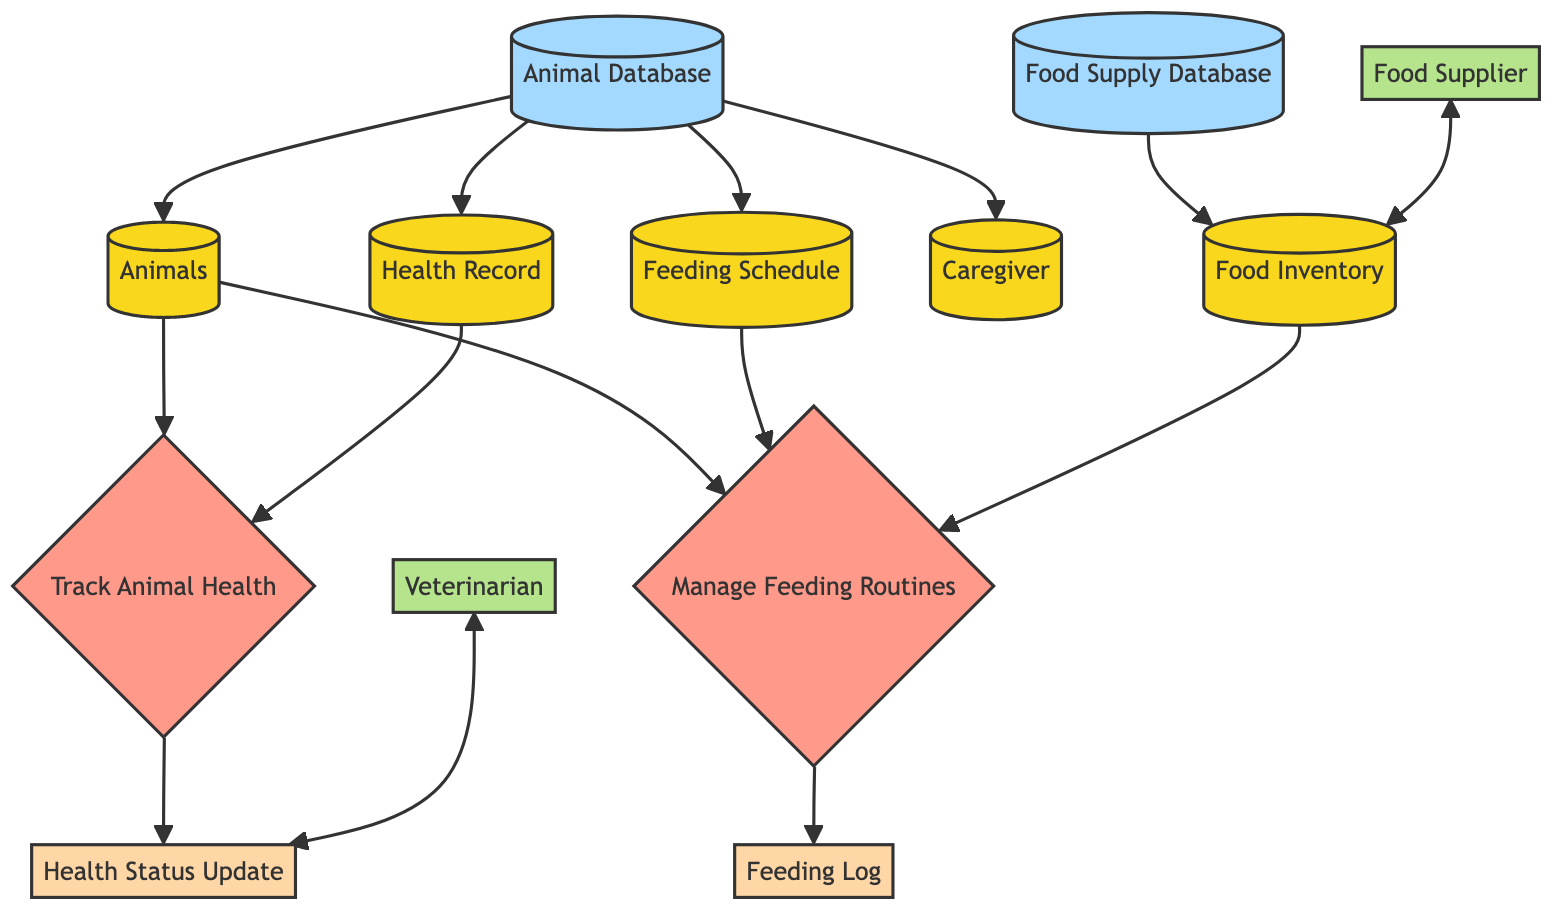What is the process that handles animal health tracking? The diagram shows a process node labeled "Track Animal Health," which is responsible for managing health records and updating health status. It takes input from "HealthRecord" and "AnimalID" and produces an output "HealthStatusUpdate."
Answer: Track Animal Health How many entities are there in the diagram? By counting the nodes labeled as entities, we identify five: "Animals," "Feeding Schedule," "Health Record," "Caregiver," and "Food Inventory."
Answer: 5 What is the output generated by the process "Manage Feeding Routines"? Following the flowchart, the output node that is linked from the "Manage Feeding Routines" process is labeled "Feeding Log," showing that this process produces a log related to feeding activities.
Answer: Feeding Log Which external entity interacts with the "Health Status Update"? The diagram indicates that there is a two-way interaction labeled between the "Veterinarian" external entity and the output "Health Status Update," meaning the veterinarian is involved in this aspect of the system.
Answer: Veterinarian Which data store contains information about animals and health records? In the diagram, the data store named "Animal Database" contains data about animals, health records, feeding schedules, and caregivers, indicating that this is the primary store for this type of information.
Answer: Animal Database What input does the "Track Animal Health" process require? The input for the "Track Animal Health" process comes from "HealthRecord" and "AnimalID" as defined in the flowchart, meaning both pieces of information are necessary for it to function.
Answer: HealthRecord, AnimalID How many outputs does the "Manage Feeding Routines" process produce? The flowchart shows that the "Manage Feeding Routines" process has a single output, which is "Feeding Log." There are no other outputs connected to this process, confirming its singular output action.
Answer: 1 Which entity is responsible for providing food inventory updates? The diagram shows that the interaction with "Food Supplier" is intended for updates related to "Food Inventory," signifying the supplier's role in maintaining the inventory levels.
Answer: Food Supplier 